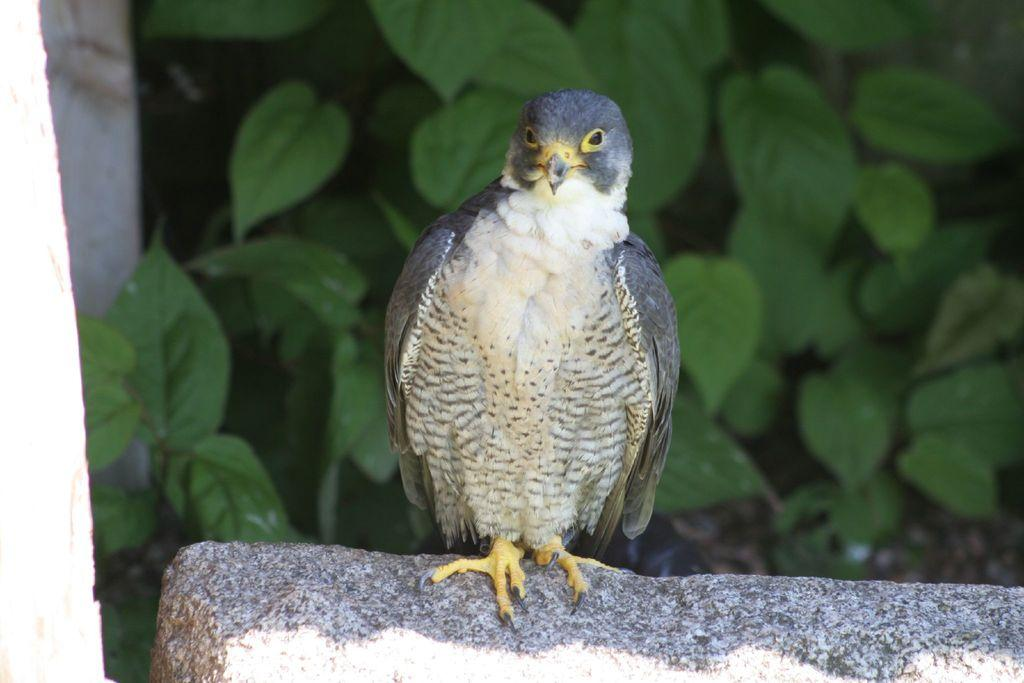What type of animal is present in the image? There is a bird in the image. Where is the bird located? The bird is on a rock. What other elements can be seen in the image? There are plants visible in the image. How many sinks are visible in the image? There are no sinks present in the image. What type of roof is covering the bird in the image? There is no roof present in the image, as the bird is on a rock outdoors. 